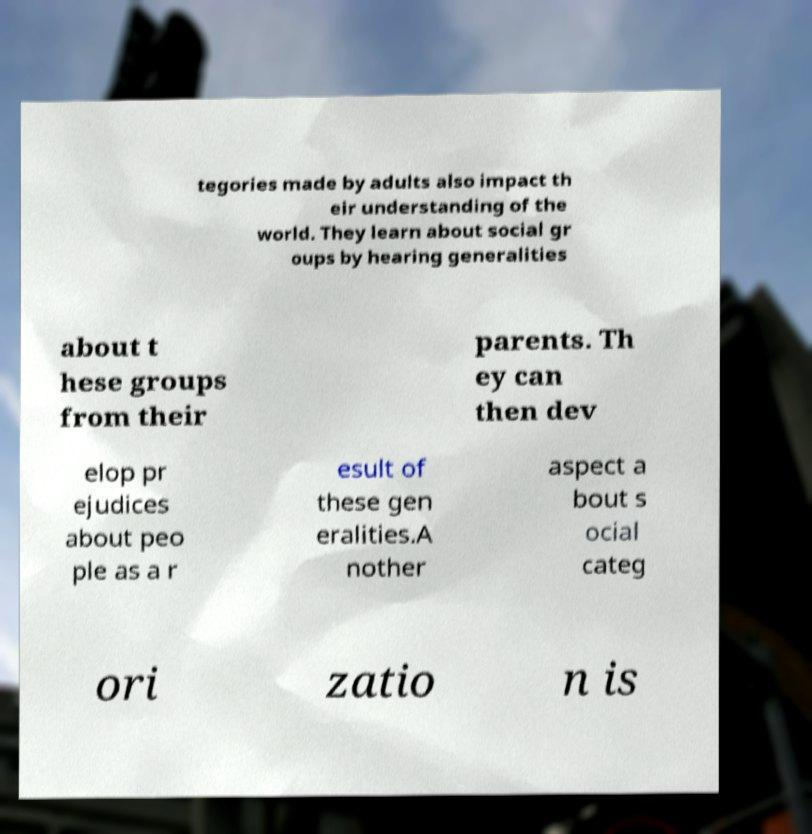Please identify and transcribe the text found in this image. tegories made by adults also impact th eir understanding of the world. They learn about social gr oups by hearing generalities about t hese groups from their parents. Th ey can then dev elop pr ejudices about peo ple as a r esult of these gen eralities.A nother aspect a bout s ocial categ ori zatio n is 